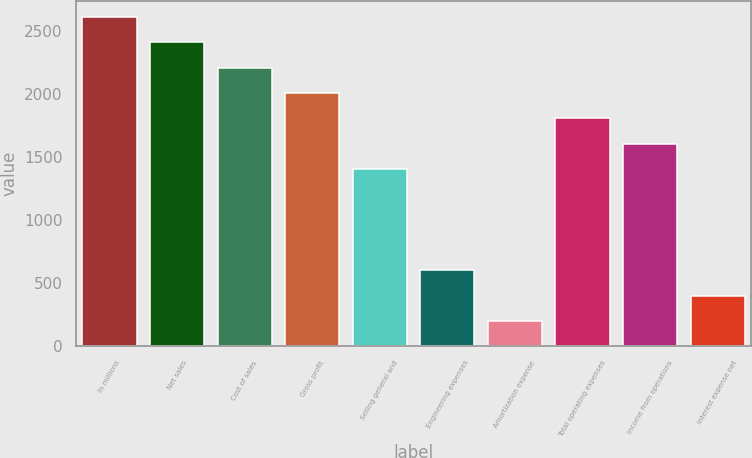Convert chart. <chart><loc_0><loc_0><loc_500><loc_500><bar_chart><fcel>In millions<fcel>Net sales<fcel>Cost of sales<fcel>Gross profit<fcel>Selling general and<fcel>Engineering expenses<fcel>Amortization expense<fcel>Total operating expenses<fcel>Income from operations<fcel>Interest expense net<nl><fcel>2612.97<fcel>2411.98<fcel>2210.99<fcel>2010<fcel>1407.03<fcel>603.07<fcel>201.09<fcel>1809.01<fcel>1608.02<fcel>402.08<nl></chart> 